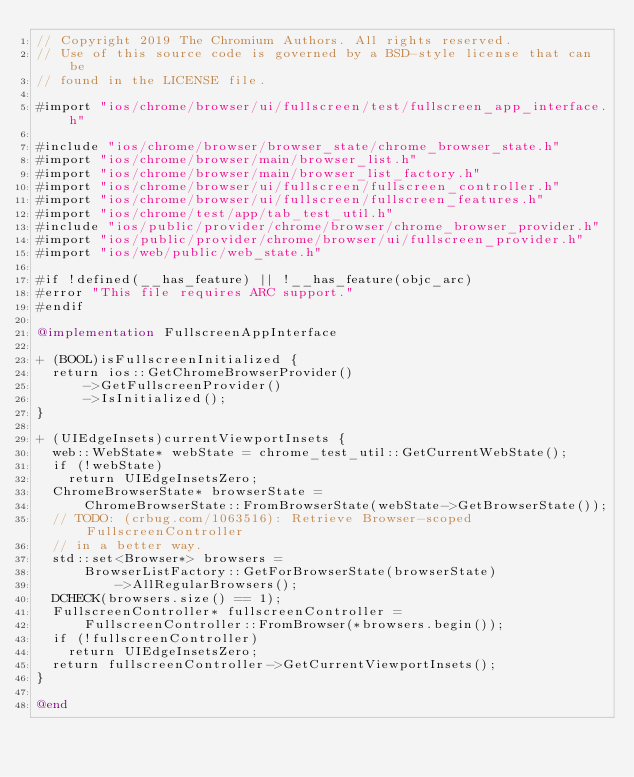Convert code to text. <code><loc_0><loc_0><loc_500><loc_500><_ObjectiveC_>// Copyright 2019 The Chromium Authors. All rights reserved.
// Use of this source code is governed by a BSD-style license that can be
// found in the LICENSE file.

#import "ios/chrome/browser/ui/fullscreen/test/fullscreen_app_interface.h"

#include "ios/chrome/browser/browser_state/chrome_browser_state.h"
#import "ios/chrome/browser/main/browser_list.h"
#import "ios/chrome/browser/main/browser_list_factory.h"
#import "ios/chrome/browser/ui/fullscreen/fullscreen_controller.h"
#import "ios/chrome/browser/ui/fullscreen/fullscreen_features.h"
#import "ios/chrome/test/app/tab_test_util.h"
#include "ios/public/provider/chrome/browser/chrome_browser_provider.h"
#import "ios/public/provider/chrome/browser/ui/fullscreen_provider.h"
#import "ios/web/public/web_state.h"

#if !defined(__has_feature) || !__has_feature(objc_arc)
#error "This file requires ARC support."
#endif

@implementation FullscreenAppInterface

+ (BOOL)isFullscreenInitialized {
  return ios::GetChromeBrowserProvider()
      ->GetFullscreenProvider()
      ->IsInitialized();
}

+ (UIEdgeInsets)currentViewportInsets {
  web::WebState* webState = chrome_test_util::GetCurrentWebState();
  if (!webState)
    return UIEdgeInsetsZero;
  ChromeBrowserState* browserState =
      ChromeBrowserState::FromBrowserState(webState->GetBrowserState());
  // TODO: (crbug.com/1063516): Retrieve Browser-scoped FullscreenController
  // in a better way.
  std::set<Browser*> browsers =
      BrowserListFactory::GetForBrowserState(browserState)
          ->AllRegularBrowsers();
  DCHECK(browsers.size() == 1);
  FullscreenController* fullscreenController =
      FullscreenController::FromBrowser(*browsers.begin());
  if (!fullscreenController)
    return UIEdgeInsetsZero;
  return fullscreenController->GetCurrentViewportInsets();
}

@end
</code> 